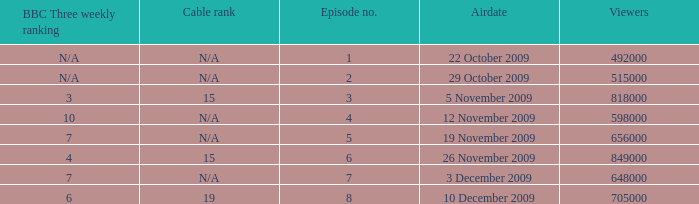What is the cable rank for the airdate of 10 december 2009? 19.0. 